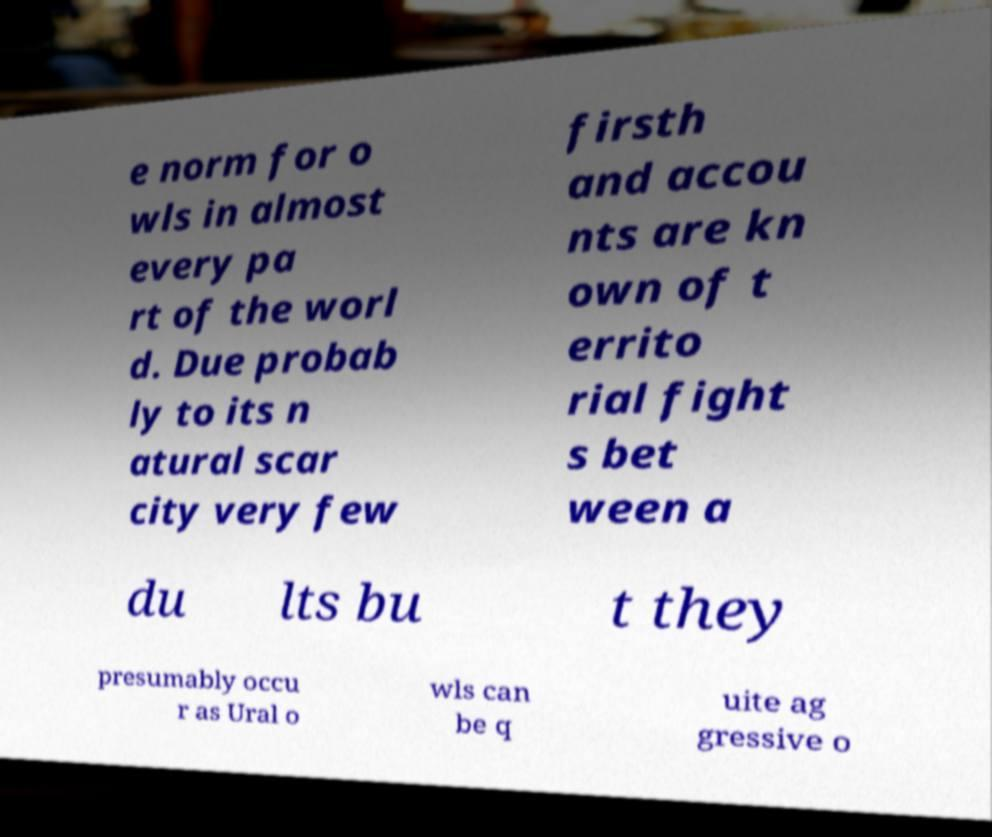Please read and relay the text visible in this image. What does it say? e norm for o wls in almost every pa rt of the worl d. Due probab ly to its n atural scar city very few firsth and accou nts are kn own of t errito rial fight s bet ween a du lts bu t they presumably occu r as Ural o wls can be q uite ag gressive o 